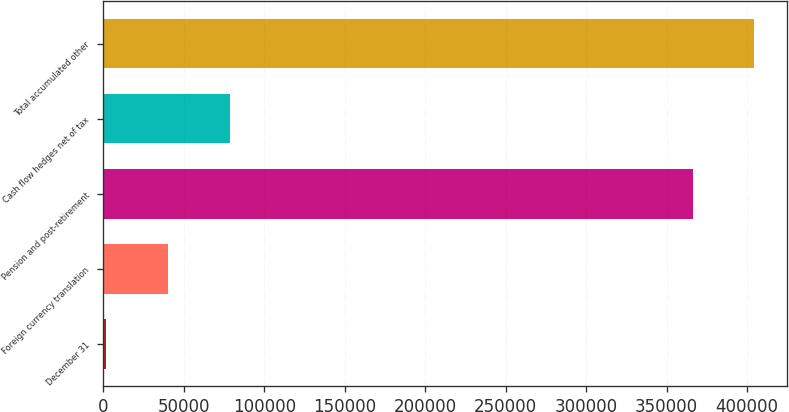<chart> <loc_0><loc_0><loc_500><loc_500><bar_chart><fcel>December 31<fcel>Foreign currency translation<fcel>Pension and post-retirement<fcel>Cash flow hedges net of tax<fcel>Total accumulated other<nl><fcel>2012<fcel>40318.4<fcel>366037<fcel>78624.8<fcel>404343<nl></chart> 